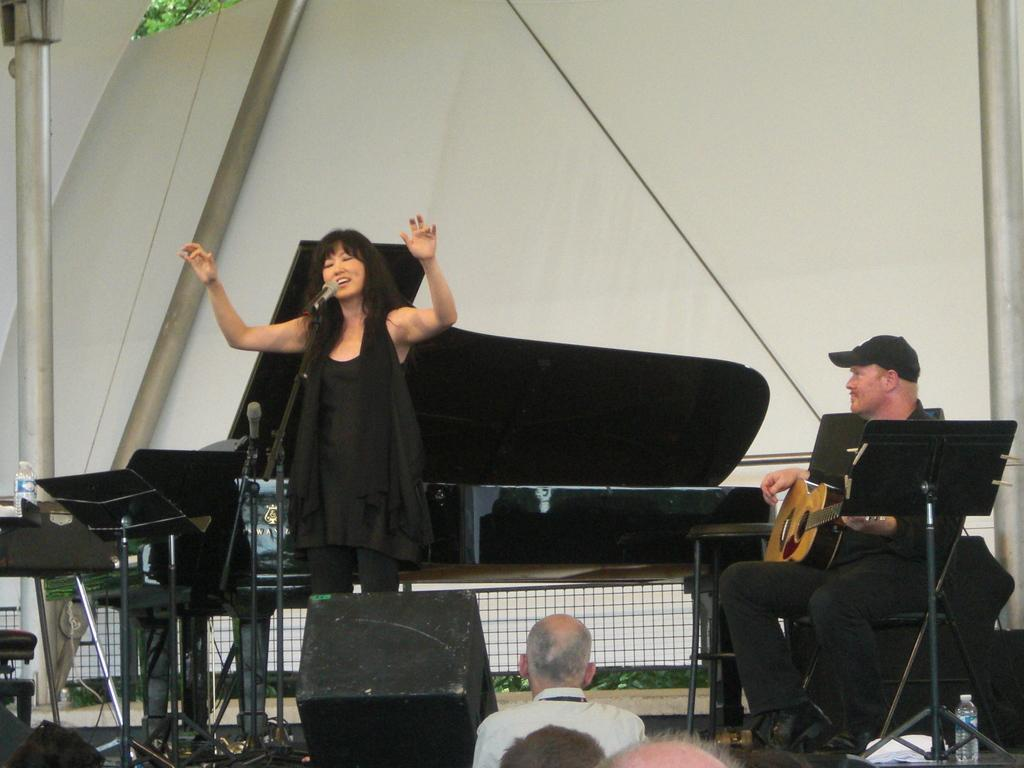What is the woman in the image doing? The woman is standing and singing in the image. What is the woman wearing? The woman is wearing a black dress in the image. Who else is present in the image? There is a man in the image. What is the man doing? The man is sitting and playing the guitar in the image. What is the man wearing? The man is wearing a black dress and a cap in the image. What type of bait is the woman using to catch fish in the image? There is no indication of fishing or bait in the image; the woman is singing and the man is playing the guitar. 